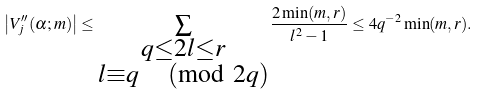<formula> <loc_0><loc_0><loc_500><loc_500>\left | V _ { j } ^ { \prime \prime } ( \alpha ; m ) \right | \leq \sum _ { \substack { q \leq 2 l \leq r \\ l \equiv q \, \pmod { 2 q } } } \frac { 2 \min ( m , r ) } { l ^ { 2 } - 1 } \leq 4 q ^ { - 2 } \min ( m , r ) .</formula> 